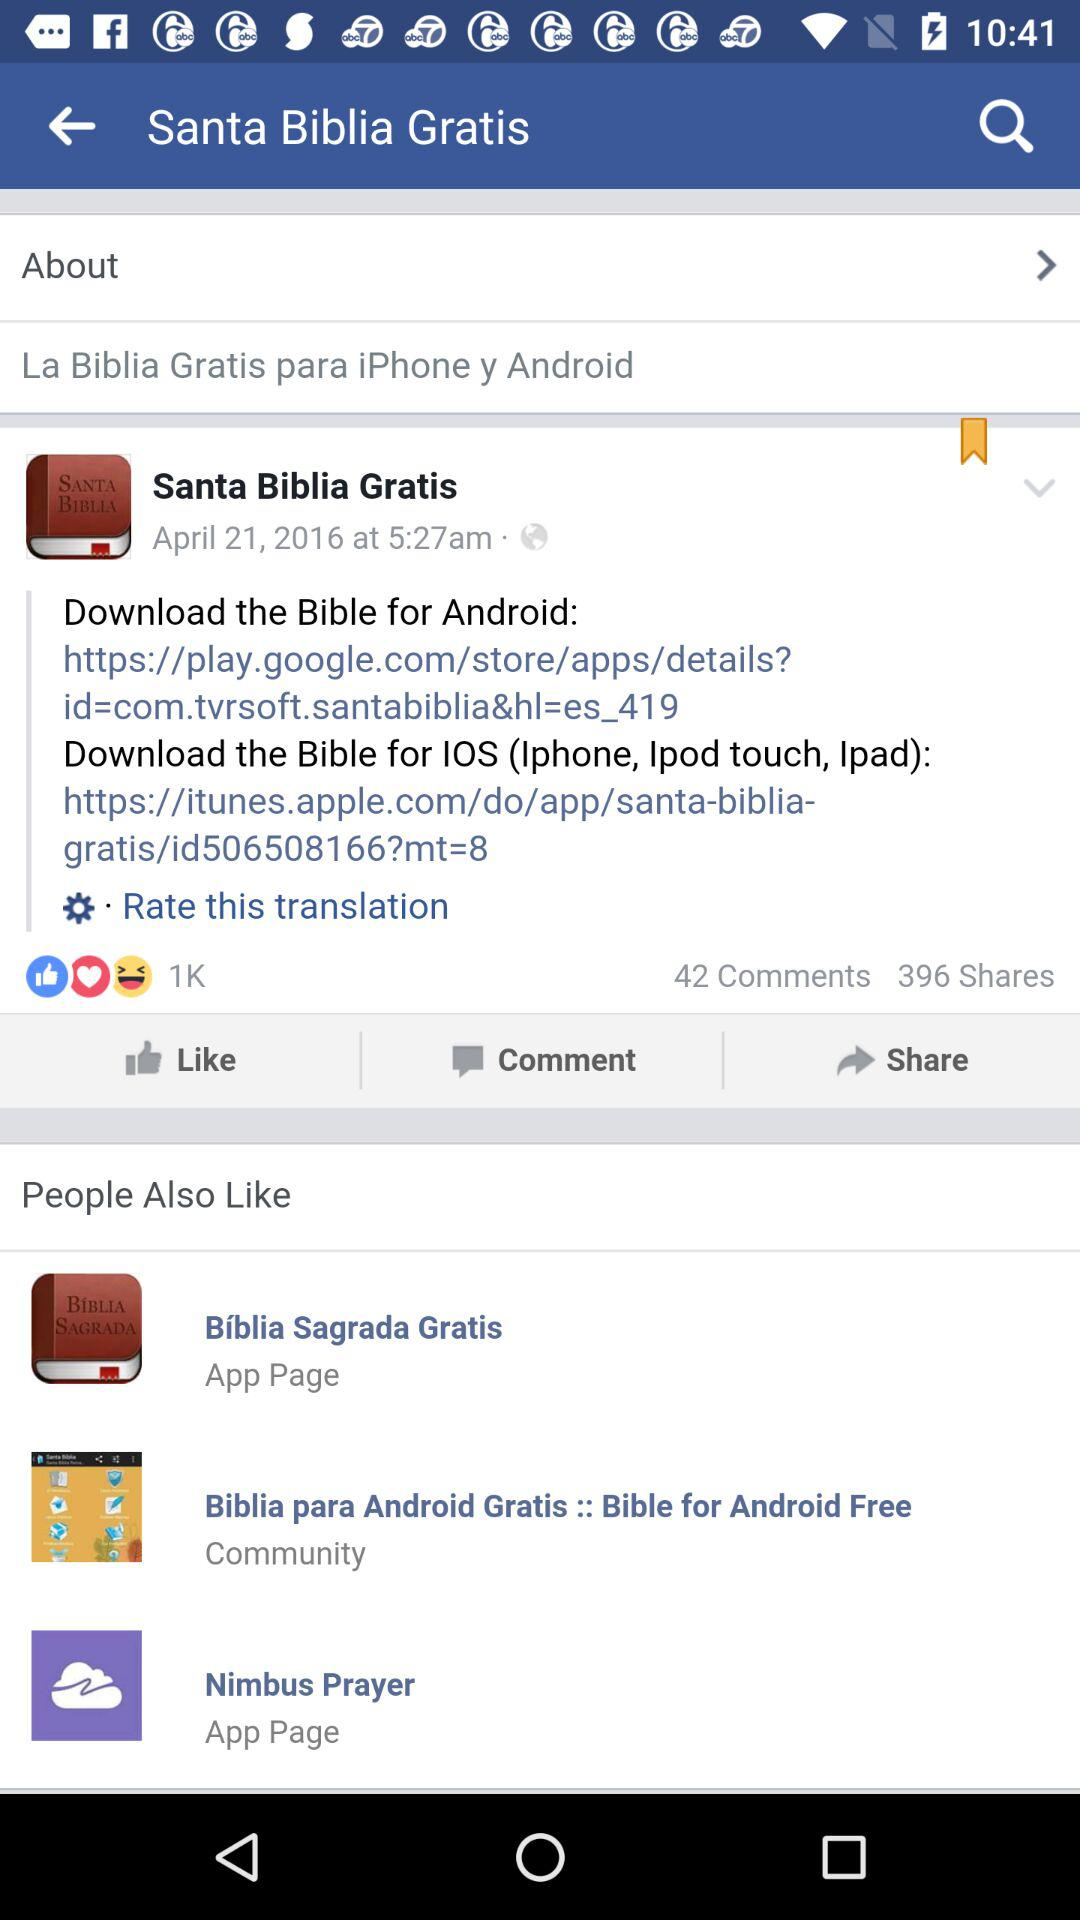How many people have shared the post? There are 396 people who have shared the post. 